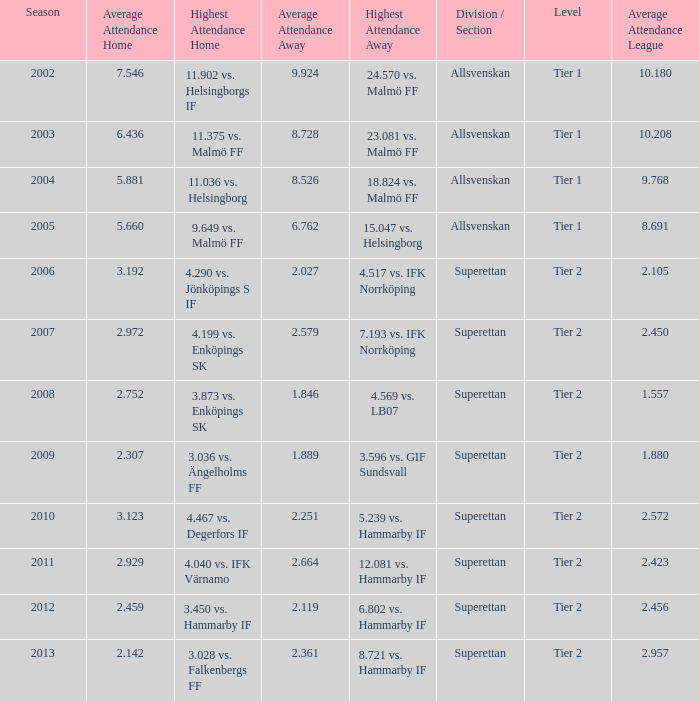How many season have an average attendance league of 2.456? 2012.0. 